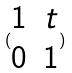<formula> <loc_0><loc_0><loc_500><loc_500>( \begin{matrix} 1 & t \\ 0 & 1 \end{matrix} )</formula> 